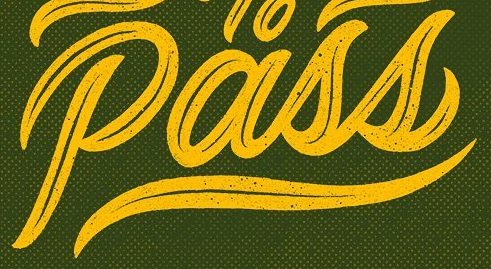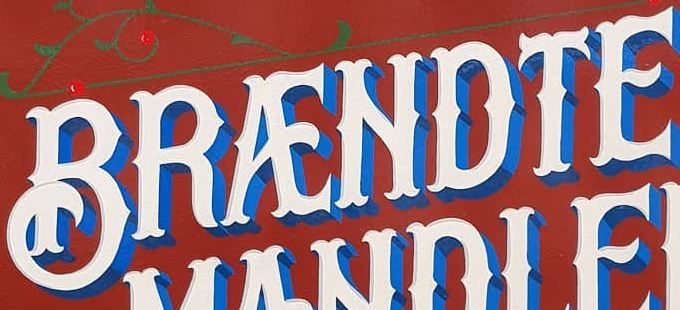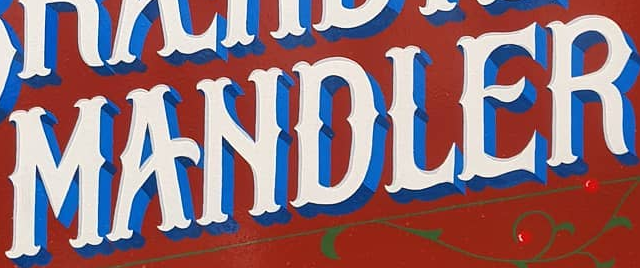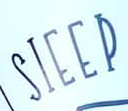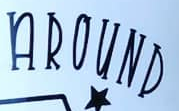What words can you see in these images in sequence, separated by a semicolon? Pass; BRÆNDTE; MANDLER; SIEEP; AROUND 